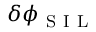<formula> <loc_0><loc_0><loc_500><loc_500>\delta \phi _ { S I L }</formula> 